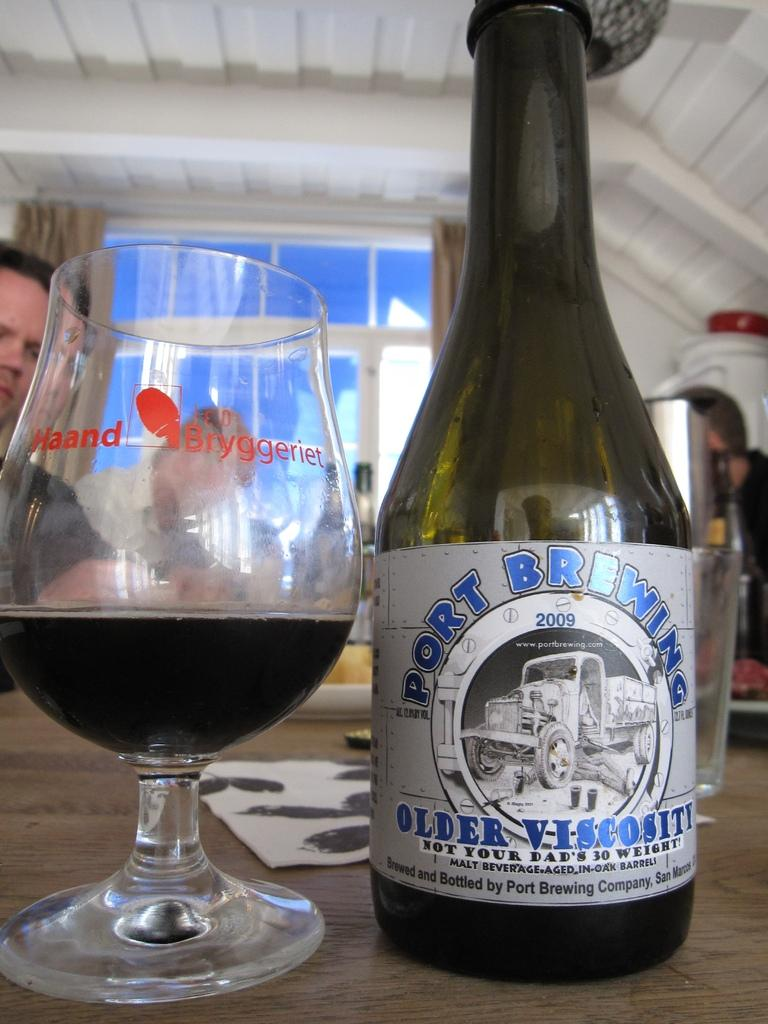What can be found in the right corner of the image? There is a wine bottle in the right corner of the image. What is located next to the wine bottle? There is a glass of wine beside the wine bottle. Can you describe the people in the background of the image? Unfortunately, the facts provided do not give any details about the people in the background. What type of basin is being used to create a rhythm in the image? There is no basin or rhythm present in the image; it features a wine bottle and a glass of wine. How does the breath of the people in the background affect the atmosphere in the image? There is no information about the people's breath or its effect on the atmosphere in the image. 